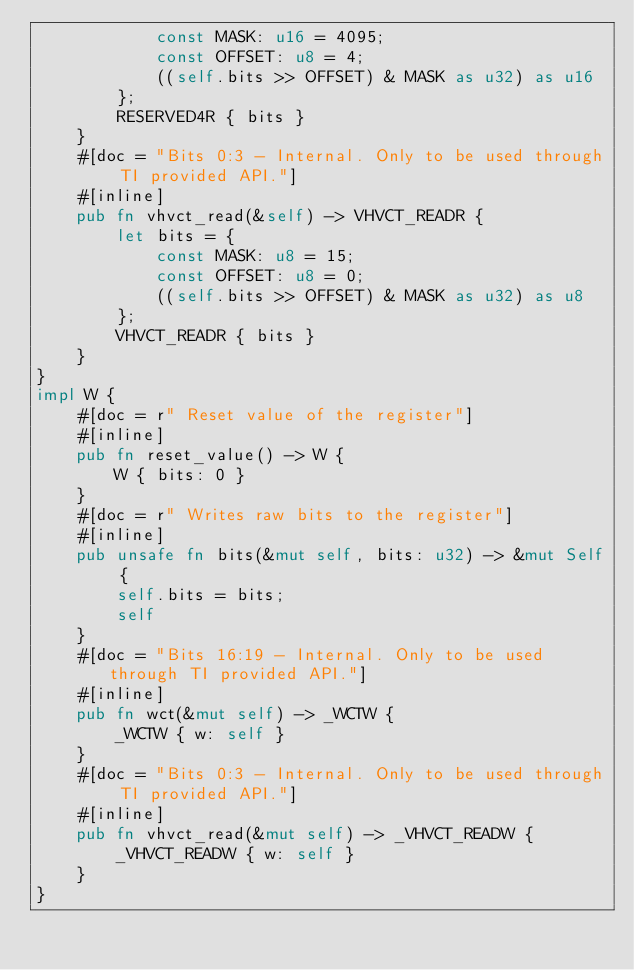Convert code to text. <code><loc_0><loc_0><loc_500><loc_500><_Rust_>            const MASK: u16 = 4095;
            const OFFSET: u8 = 4;
            ((self.bits >> OFFSET) & MASK as u32) as u16
        };
        RESERVED4R { bits }
    }
    #[doc = "Bits 0:3 - Internal. Only to be used through TI provided API."]
    #[inline]
    pub fn vhvct_read(&self) -> VHVCT_READR {
        let bits = {
            const MASK: u8 = 15;
            const OFFSET: u8 = 0;
            ((self.bits >> OFFSET) & MASK as u32) as u8
        };
        VHVCT_READR { bits }
    }
}
impl W {
    #[doc = r" Reset value of the register"]
    #[inline]
    pub fn reset_value() -> W {
        W { bits: 0 }
    }
    #[doc = r" Writes raw bits to the register"]
    #[inline]
    pub unsafe fn bits(&mut self, bits: u32) -> &mut Self {
        self.bits = bits;
        self
    }
    #[doc = "Bits 16:19 - Internal. Only to be used through TI provided API."]
    #[inline]
    pub fn wct(&mut self) -> _WCTW {
        _WCTW { w: self }
    }
    #[doc = "Bits 0:3 - Internal. Only to be used through TI provided API."]
    #[inline]
    pub fn vhvct_read(&mut self) -> _VHVCT_READW {
        _VHVCT_READW { w: self }
    }
}
</code> 